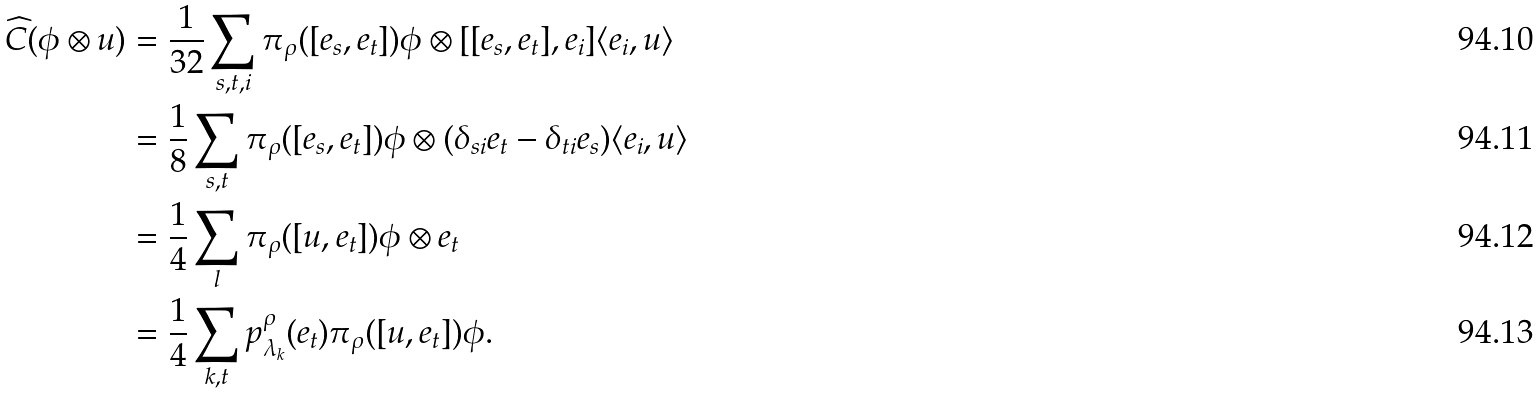<formula> <loc_0><loc_0><loc_500><loc_500>\widehat { C } ( \phi \otimes u ) & = \frac { 1 } { 3 2 } \sum _ { s , t , i } \pi _ { \rho } ( [ e _ { s } , e _ { t } ] ) \phi \otimes [ [ e _ { s } , e _ { t } ] , e _ { i } ] \langle e _ { i } , u \rangle \\ & = \frac { 1 } { 8 } \sum _ { s , t } \pi _ { \rho } ( [ e _ { s } , e _ { t } ] ) \phi \otimes ( \delta _ { s i } e _ { t } - \delta _ { t i } e _ { s } ) \langle e _ { i } , u \rangle \\ & = \frac { 1 } { 4 } \sum _ { l } \pi _ { \rho } ( [ u , e _ { t } ] ) \phi \otimes e _ { t } \\ & = \frac { 1 } { 4 } \sum _ { k , t } p ^ { \rho } _ { \lambda _ { k } } ( e _ { t } ) \pi _ { \rho } ( [ u , e _ { t } ] ) \phi .</formula> 